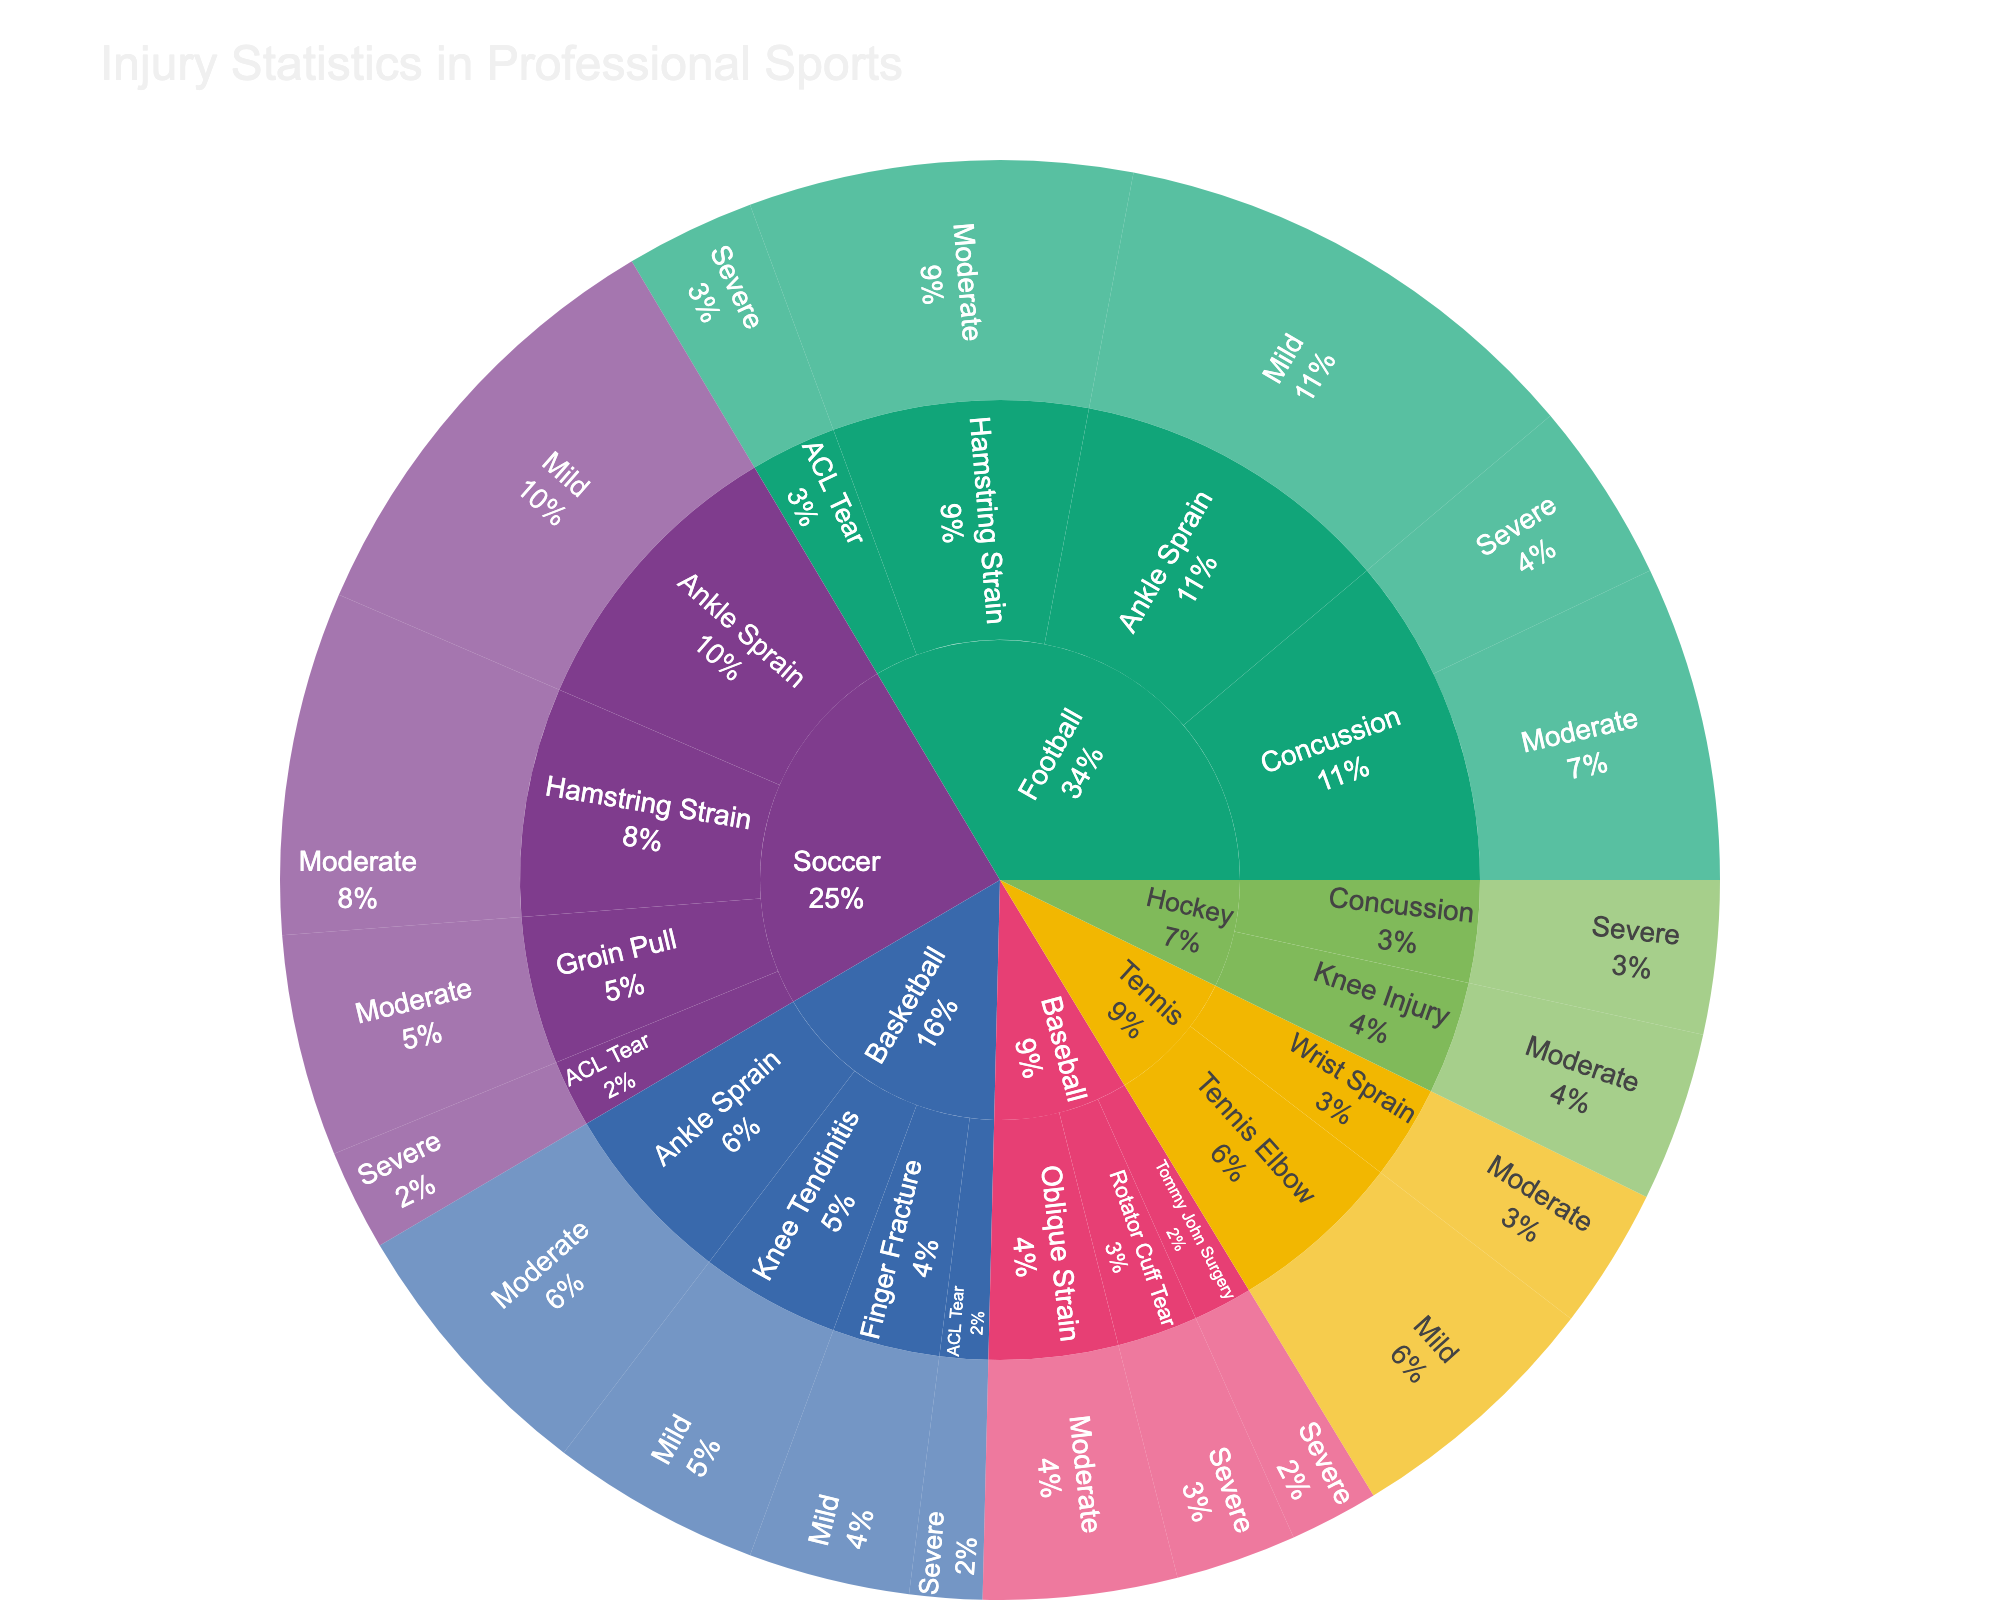What's the most common injury type in Football? To find the most common injury type in Football, look at the segments under "Football" and compare their sizes. The one with the largest segment represents the most common injury type.
Answer: Ankle Sprain What's the total count of severe injuries across all sports? Sum up the counts of all severe injuries from each sport. For Football, it's 45 (Concussion) + 32 (ACL Tear). For Basketball, 18 (ACL Tear). For Soccer, 25 (ACL Tear). For Baseball, 30 (Rotator Cuff Tear) + 22 (Tommy John Surgery). For Hockey, 38 (Concussion).
Answer: 210 Which sport has the highest number of injuries? Compare the total size of each sport segment to find which one is the largest. The sport with the largest total value has the highest number of injuries.
Answer: Football How many mild injuries occurred in Tennis? Look for the "Tennis" section and find the total number of mild injuries listed under it.
Answer: 65 What's the percentage of moderate injuries in Soccer? First, find the total number of moderate injuries in Soccer by summing the moderate incident counts. Then, sum up all Soccer injury counts. The percentage is (total moderate counts)/(overall counts in Soccer)*100. Total moderate: 85 (Hamstring Strain) + 55 (Groin Pull) = 140. Total injuries: 85 (Hamstring Strain) + 110 (Ankle Sprain) + 55 (Groin Pull) + 25 (ACL Tear) = 275. Percentage is 140/275 * 100.
Answer: 50.91% Are there more severe or moderate ACL Tear injuries in Football? Compare the counts of severe and moderate "ACL Tear" injuries under the Football section.
Answer: Moderate What's the least common injury type in Baseball? Within the "Baseball" section, compare the sizes of the segments to find the one with the smallest count.
Answer: Tommy John Surgery How frequently do concussions occur in Hockey compared to Football? Locate the segments for Concussions in both Hockey and Football, then compare their counts. Football has 45, Hockey has 38.
Answer: More in Football What is the count of all injuries in Basketball? Add up the counts of all injury types listed under "Basketball." 68 (Ankle Sprain) + 52 (Knee Tendinitis) + 18 (ACL Tear) + 40 (Finger Fracture).
Answer: 178 Which injury type in Football has the highest severity? Under the "Football" section, look at injury types and compare their segments labeled "Severe".
Answer: Concussion 